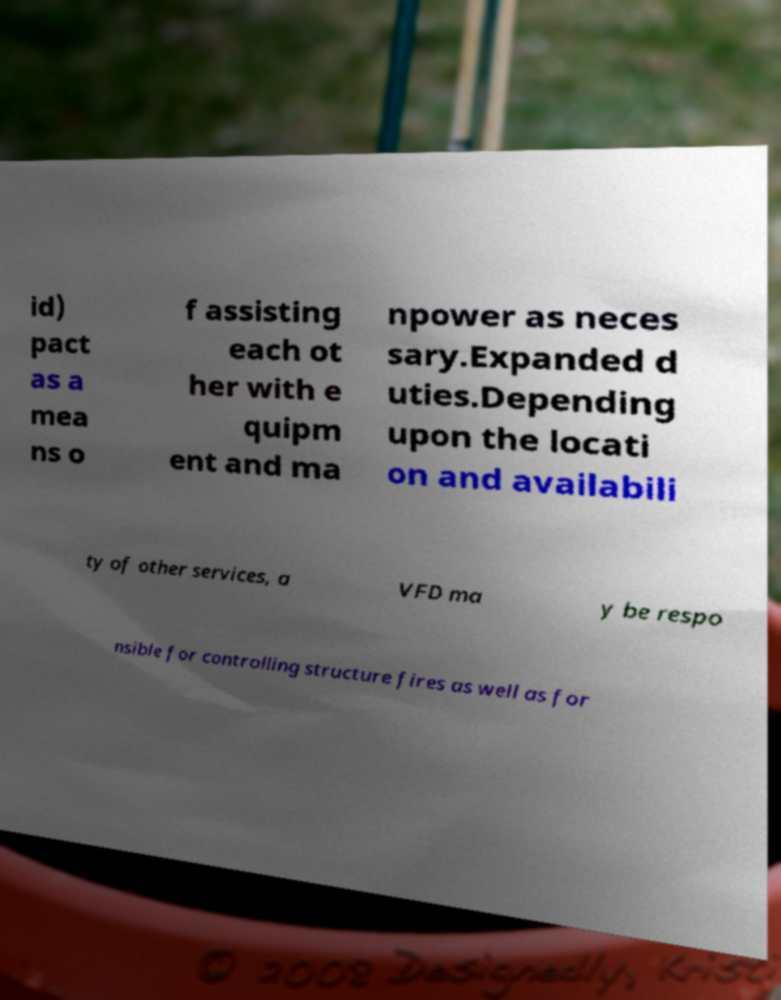Can you accurately transcribe the text from the provided image for me? id) pact as a mea ns o f assisting each ot her with e quipm ent and ma npower as neces sary.Expanded d uties.Depending upon the locati on and availabili ty of other services, a VFD ma y be respo nsible for controlling structure fires as well as for 